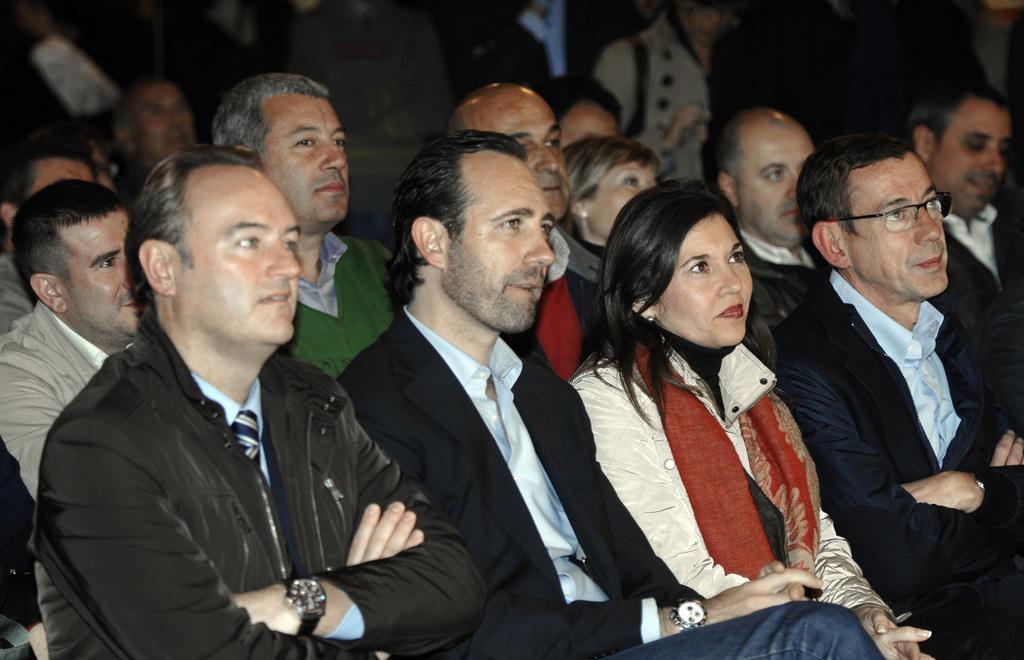How would you summarize this image in a sentence or two? This image consists of few persons. In the front, we can see three men and a woman are sitting. 